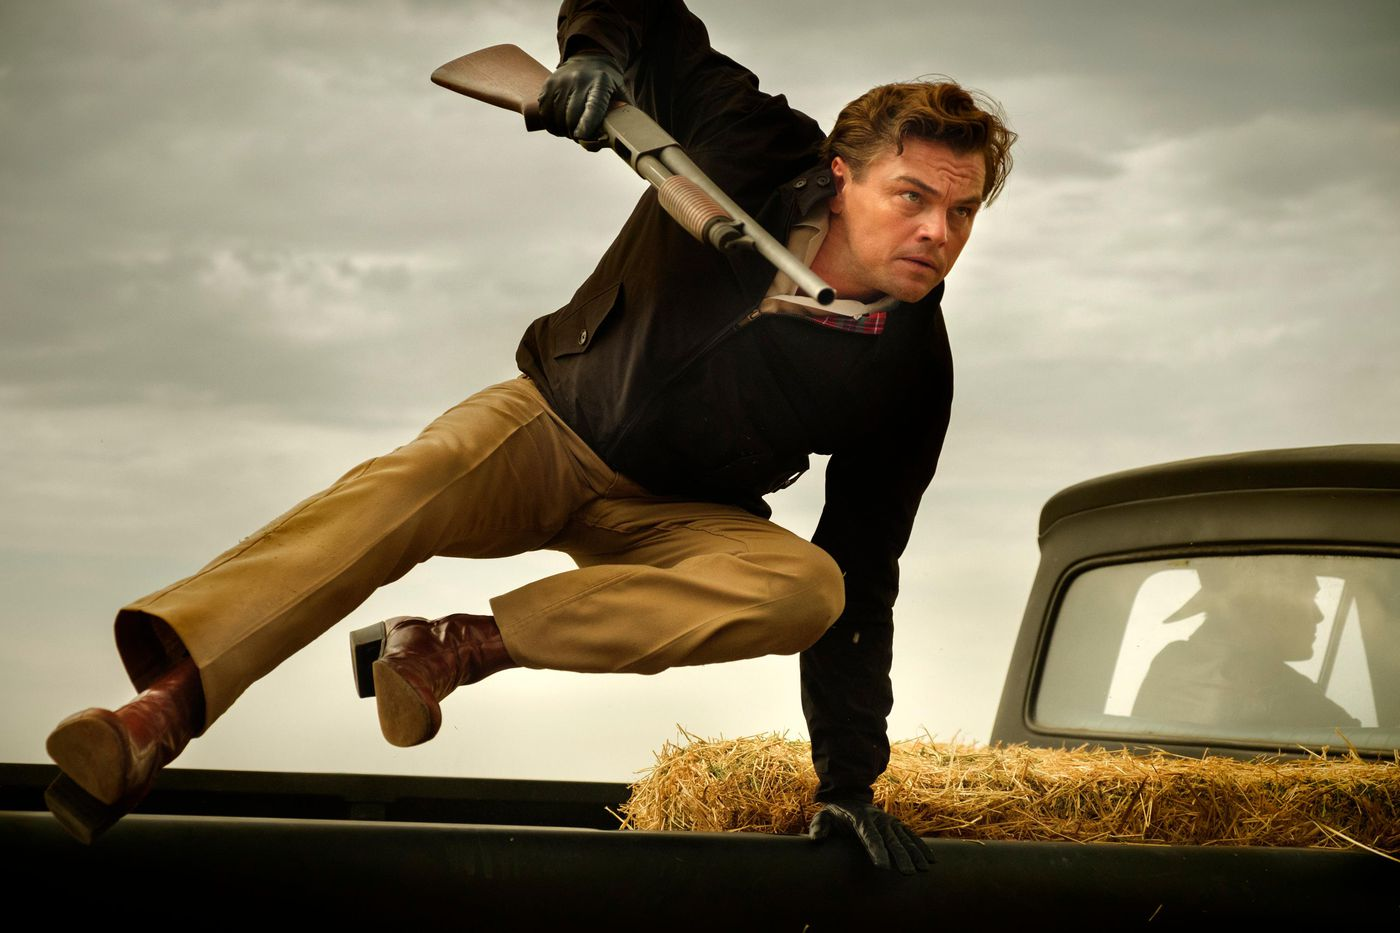Imagine what happens immediately after this scene. Immediately after this scene, the man could land gracefully on the other side of the car, maintaining his grip on the shotgun. He would quickly scan his surroundings for any imminent threats or targets. If he's in pursuit, he'd continue running with determined strides, moving towards his goal with relentless focus. Alternatively, if he’s defending himself, he might take cover behind the car, using it as a shield while he assesses the situation. The tension remains high, with the cloudy sky emphasizing the potential for more dramatic developments. 